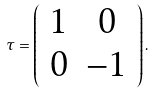Convert formula to latex. <formula><loc_0><loc_0><loc_500><loc_500>\tau = \left ( \begin{array} { c c } 1 & 0 \\ 0 & - 1 \end{array} \right ) .</formula> 